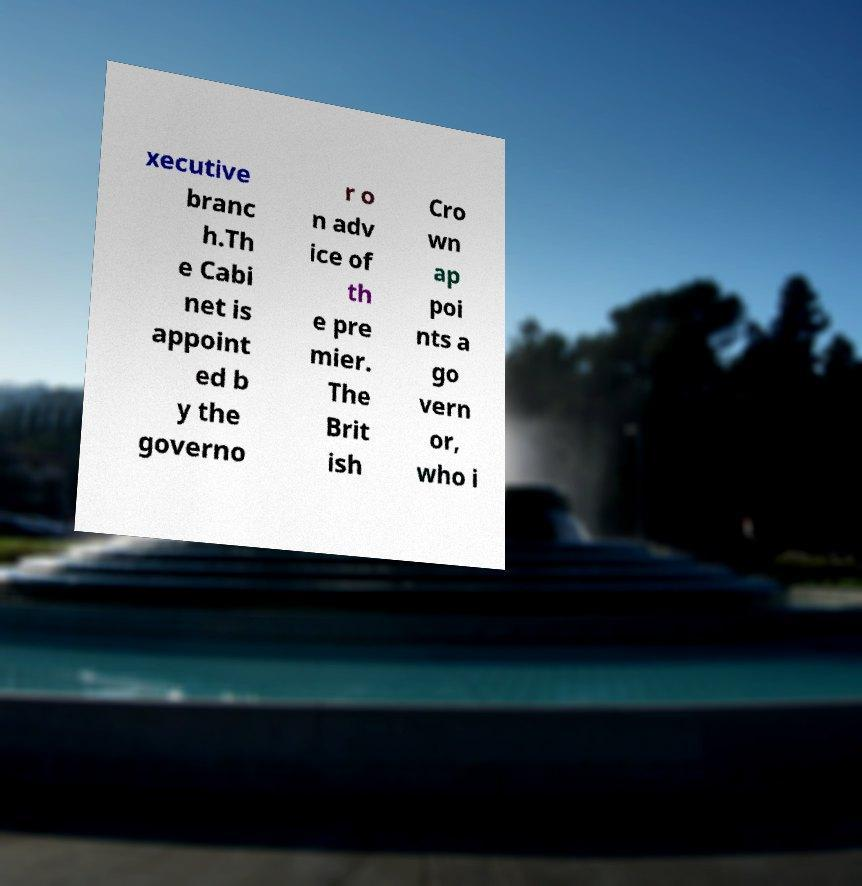Could you assist in decoding the text presented in this image and type it out clearly? xecutive branc h.Th e Cabi net is appoint ed b y the governo r o n adv ice of th e pre mier. The Brit ish Cro wn ap poi nts a go vern or, who i 